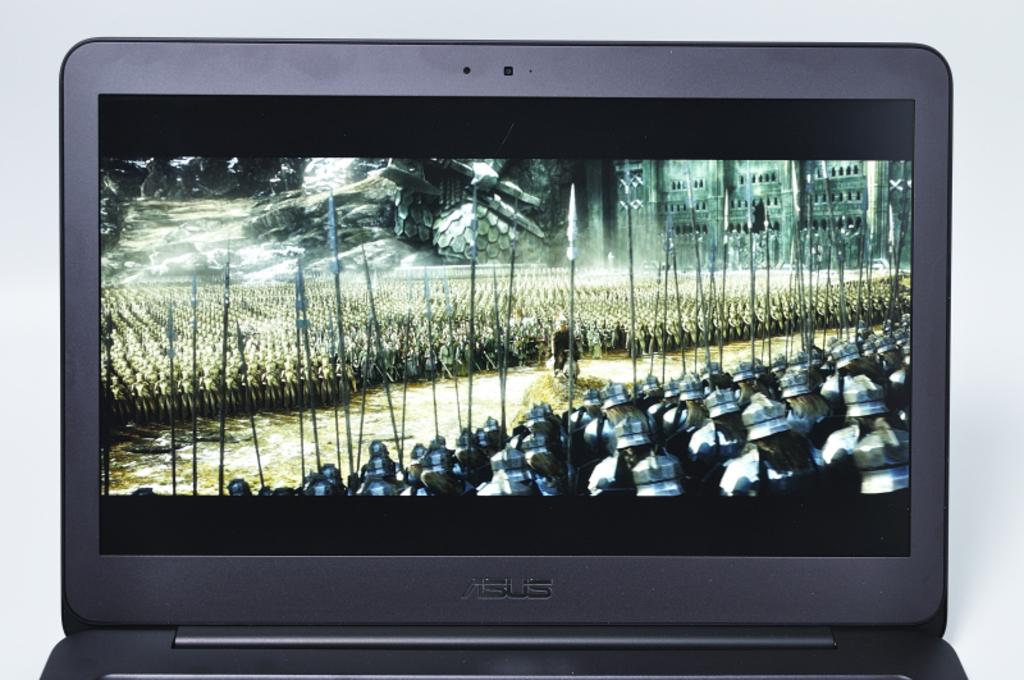<image>
Relay a brief, clear account of the picture shown. an asus laptop with a bunch of warriors on the screen 